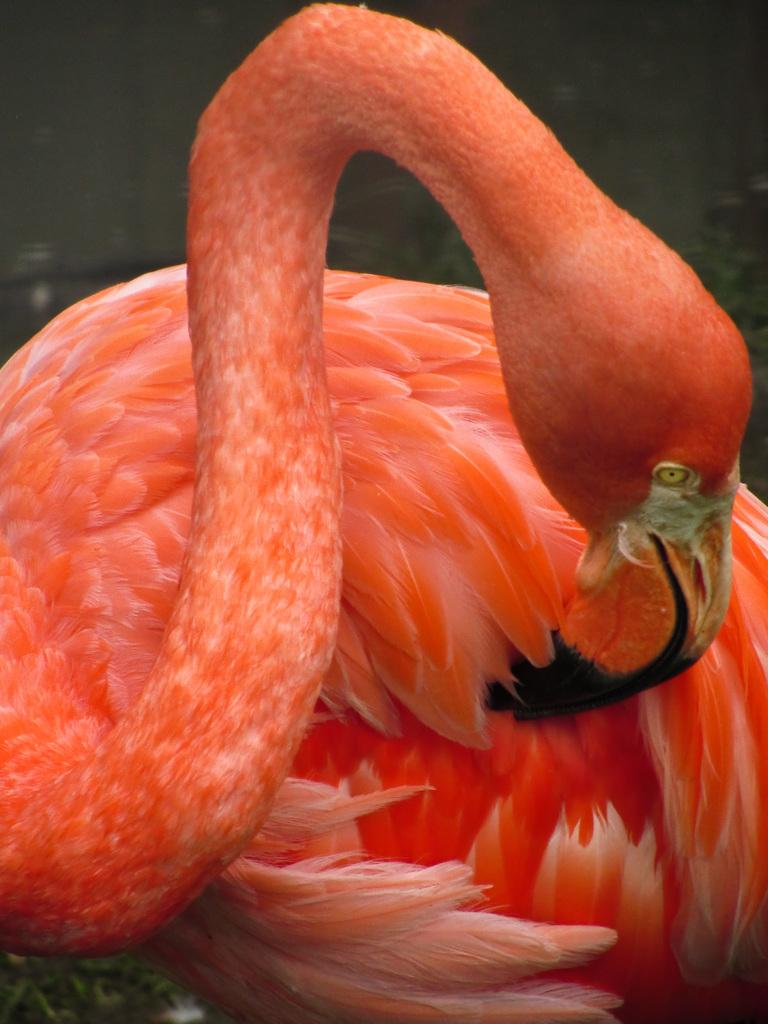What type of animal is in the image? There is a swan in the image. What color is the swan? The swan is orange in color. How is the swan described? The swan is described as beautiful. How much copper is present in the swan's feathers in the image? There is no mention of copper or its presence in the swan's feathers in the image. 